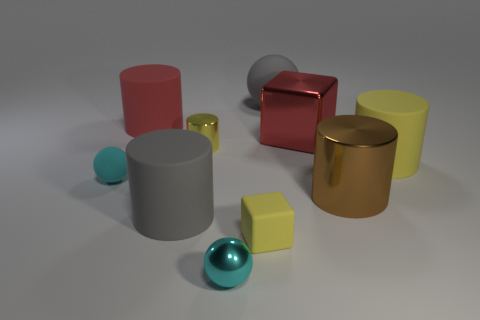Subtract all brown metallic cylinders. How many cylinders are left? 4 Subtract all gray cylinders. How many cylinders are left? 4 Subtract all cyan cylinders. Subtract all cyan spheres. How many cylinders are left? 5 Subtract all spheres. How many objects are left? 7 Subtract 0 blue balls. How many objects are left? 10 Subtract all tiny matte things. Subtract all cyan metallic objects. How many objects are left? 7 Add 6 big gray cylinders. How many big gray cylinders are left? 7 Add 1 metallic things. How many metallic things exist? 5 